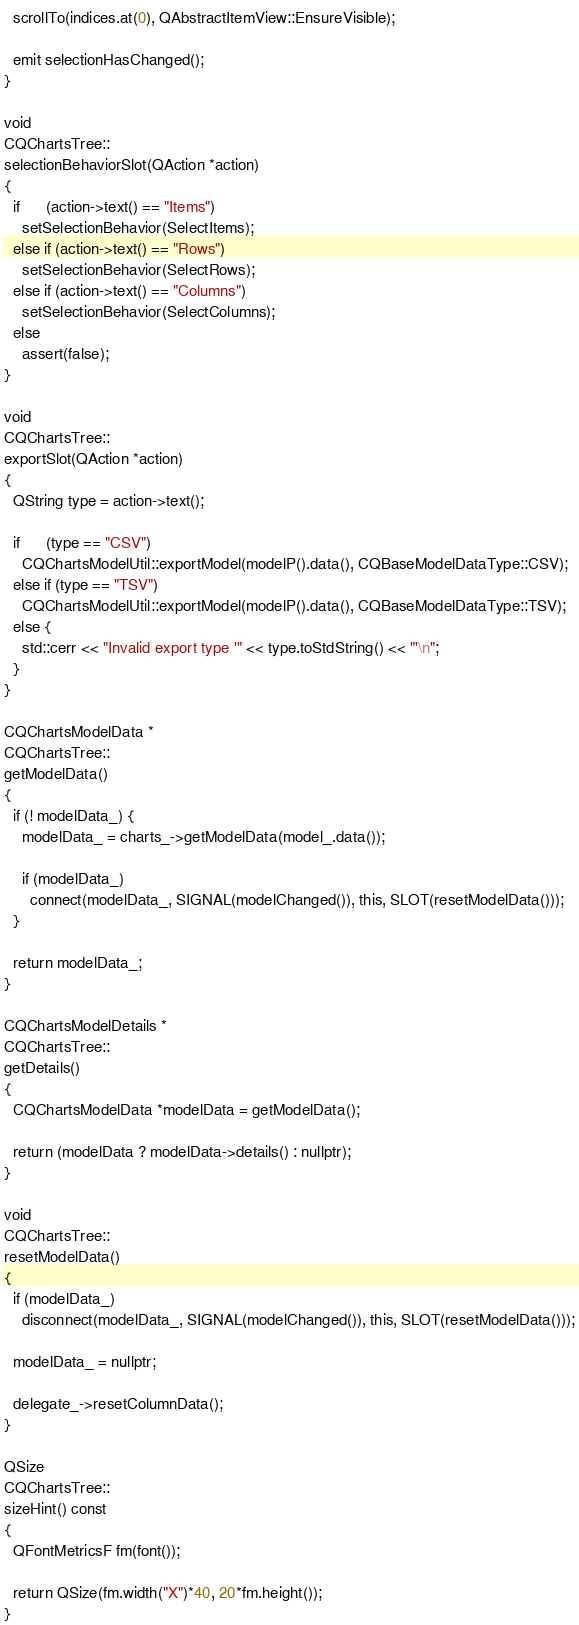Convert code to text. <code><loc_0><loc_0><loc_500><loc_500><_C++_>  scrollTo(indices.at(0), QAbstractItemView::EnsureVisible);

  emit selectionHasChanged();
}

void
CQChartsTree::
selectionBehaviorSlot(QAction *action)
{
  if      (action->text() == "Items")
    setSelectionBehavior(SelectItems);
  else if (action->text() == "Rows")
    setSelectionBehavior(SelectRows);
  else if (action->text() == "Columns")
    setSelectionBehavior(SelectColumns);
  else
    assert(false);
}

void
CQChartsTree::
exportSlot(QAction *action)
{
  QString type = action->text();

  if      (type == "CSV")
    CQChartsModelUtil::exportModel(modelP().data(), CQBaseModelDataType::CSV);
  else if (type == "TSV")
    CQChartsModelUtil::exportModel(modelP().data(), CQBaseModelDataType::TSV);
  else {
    std::cerr << "Invalid export type '" << type.toStdString() << "'\n";
  }
}

CQChartsModelData *
CQChartsTree::
getModelData()
{
  if (! modelData_) {
    modelData_ = charts_->getModelData(model_.data());

    if (modelData_)
      connect(modelData_, SIGNAL(modelChanged()), this, SLOT(resetModelData()));
  }

  return modelData_;
}

CQChartsModelDetails *
CQChartsTree::
getDetails()
{
  CQChartsModelData *modelData = getModelData();

  return (modelData ? modelData->details() : nullptr);
}

void
CQChartsTree::
resetModelData()
{
  if (modelData_)
    disconnect(modelData_, SIGNAL(modelChanged()), this, SLOT(resetModelData()));

  modelData_ = nullptr;

  delegate_->resetColumnData();
}

QSize
CQChartsTree::
sizeHint() const
{
  QFontMetricsF fm(font());

  return QSize(fm.width("X")*40, 20*fm.height());
}
</code> 